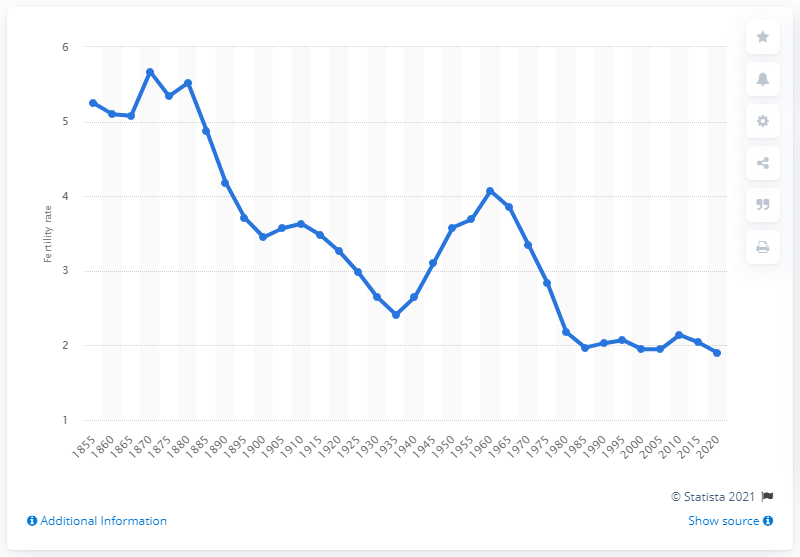Draw attention to some important aspects in this diagram. In 1855, the average number of children born to women of childbearing age in New Zealand was 5.3. 